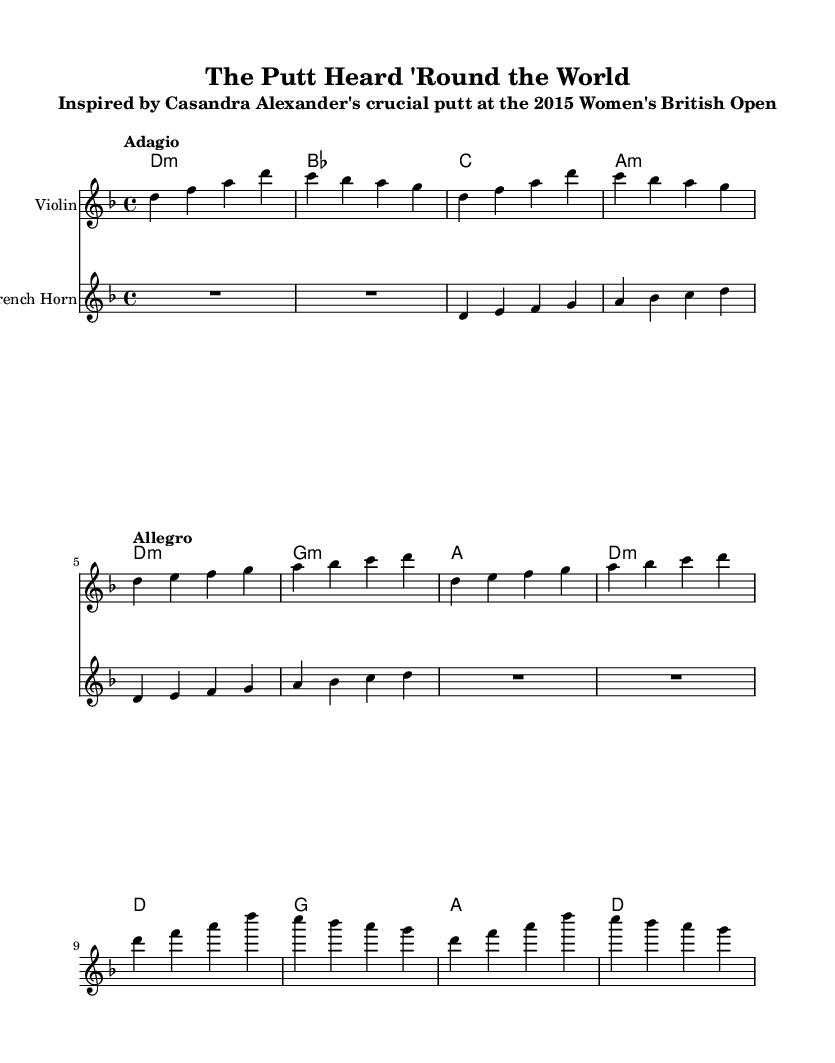What is the key signature of this music? The key signature is D minor, which has one flat (B flat).
Answer: D minor What is the time signature of this music? The time signature is four-four, as indicated by the "4/4" notation at the beginning.
Answer: Four-four What is the tempo marking for the first section? The tempo marking for the first section is "Adagio," indicating a slow tempo.
Answer: Adagio How many measures are there in total for the "Triumph" section? The "Triumph" section consists of four measures, as counted from the music.
Answer: Four What is the primary instrument featured in this score? The primary instrument featured in this score is the violin, as indicated at the beginning of the violin staff.
Answer: Violin How does the tempo change between "The Putt" and "Triumph"? The tempo changes from "Allegro" in "The Putt" to no specific tempo marking indicated in "Triumph," suggesting a return to the previous pace.
Answer: Change in tempo What type of harmony is used during "Anticipation"? The harmony used during "Anticipation" is minor chords, specifically D minor and A minor.
Answer: Minor chords 